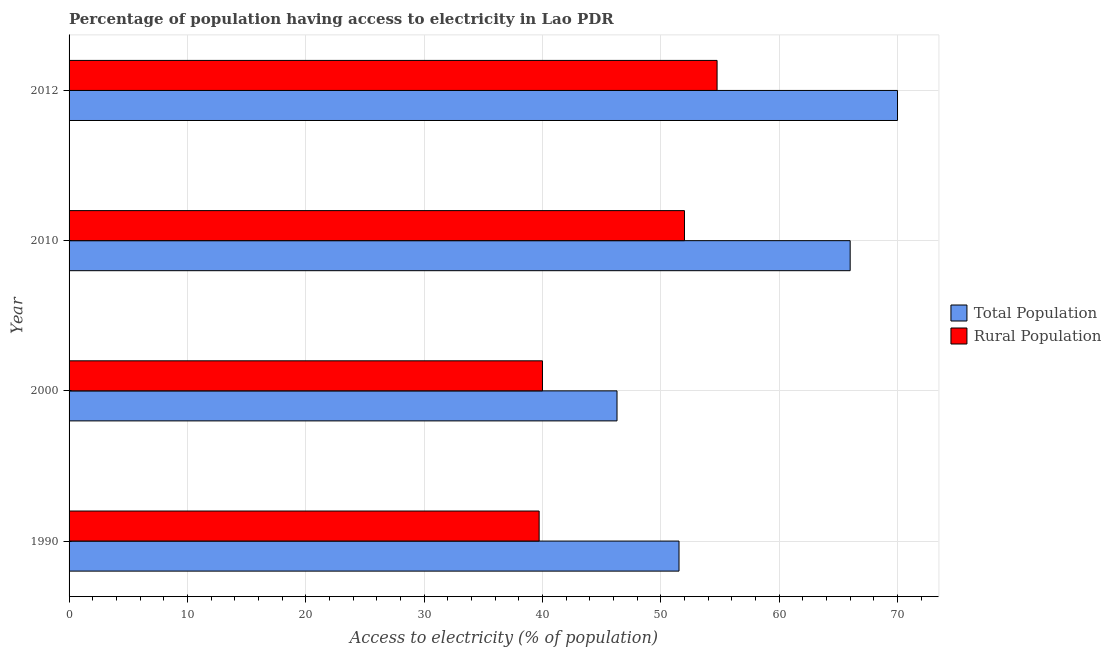How many different coloured bars are there?
Give a very brief answer. 2. How many groups of bars are there?
Offer a terse response. 4. Are the number of bars per tick equal to the number of legend labels?
Offer a very short reply. Yes. Are the number of bars on each tick of the Y-axis equal?
Offer a very short reply. Yes. How many bars are there on the 3rd tick from the bottom?
Your response must be concise. 2. In how many cases, is the number of bars for a given year not equal to the number of legend labels?
Give a very brief answer. 0. Across all years, what is the minimum percentage of population having access to electricity?
Your answer should be very brief. 46.3. In which year was the percentage of population having access to electricity maximum?
Make the answer very short. 2012. In which year was the percentage of population having access to electricity minimum?
Keep it short and to the point. 2000. What is the total percentage of population having access to electricity in the graph?
Your answer should be very brief. 233.84. What is the difference between the percentage of population having access to electricity in 1990 and that in 2012?
Your answer should be compact. -18.46. What is the difference between the percentage of rural population having access to electricity in 2012 and the percentage of population having access to electricity in 2010?
Your answer should be very brief. -11.25. What is the average percentage of population having access to electricity per year?
Your answer should be compact. 58.46. In the year 2012, what is the difference between the percentage of population having access to electricity and percentage of rural population having access to electricity?
Provide a succinct answer. 15.24. What is the ratio of the percentage of population having access to electricity in 2010 to that in 2012?
Your response must be concise. 0.94. Is the percentage of population having access to electricity in 1990 less than that in 2000?
Your answer should be very brief. No. What is the difference between the highest and the second highest percentage of population having access to electricity?
Give a very brief answer. 4. What is the difference between the highest and the lowest percentage of rural population having access to electricity?
Your answer should be very brief. 15.03. What does the 1st bar from the top in 2012 represents?
Ensure brevity in your answer.  Rural Population. What does the 2nd bar from the bottom in 1990 represents?
Your answer should be very brief. Rural Population. How many bars are there?
Your response must be concise. 8. How many years are there in the graph?
Your answer should be very brief. 4. Are the values on the major ticks of X-axis written in scientific E-notation?
Offer a terse response. No. Does the graph contain any zero values?
Offer a terse response. No. How many legend labels are there?
Your answer should be very brief. 2. What is the title of the graph?
Provide a short and direct response. Percentage of population having access to electricity in Lao PDR. Does "Quality of trade" appear as one of the legend labels in the graph?
Your response must be concise. No. What is the label or title of the X-axis?
Offer a very short reply. Access to electricity (% of population). What is the label or title of the Y-axis?
Make the answer very short. Year. What is the Access to electricity (% of population) of Total Population in 1990?
Provide a succinct answer. 51.54. What is the Access to electricity (% of population) of Rural Population in 1990?
Offer a terse response. 39.72. What is the Access to electricity (% of population) of Total Population in 2000?
Your response must be concise. 46.3. What is the Access to electricity (% of population) in Total Population in 2010?
Make the answer very short. 66. What is the Access to electricity (% of population) of Rural Population in 2010?
Keep it short and to the point. 52. What is the Access to electricity (% of population) of Total Population in 2012?
Your answer should be compact. 70. What is the Access to electricity (% of population) of Rural Population in 2012?
Provide a succinct answer. 54.75. Across all years, what is the maximum Access to electricity (% of population) of Rural Population?
Give a very brief answer. 54.75. Across all years, what is the minimum Access to electricity (% of population) of Total Population?
Offer a terse response. 46.3. Across all years, what is the minimum Access to electricity (% of population) in Rural Population?
Provide a succinct answer. 39.72. What is the total Access to electricity (% of population) of Total Population in the graph?
Offer a terse response. 233.84. What is the total Access to electricity (% of population) of Rural Population in the graph?
Keep it short and to the point. 186.47. What is the difference between the Access to electricity (% of population) in Total Population in 1990 and that in 2000?
Provide a succinct answer. 5.24. What is the difference between the Access to electricity (% of population) in Rural Population in 1990 and that in 2000?
Provide a succinct answer. -0.28. What is the difference between the Access to electricity (% of population) in Total Population in 1990 and that in 2010?
Your answer should be compact. -14.46. What is the difference between the Access to electricity (% of population) of Rural Population in 1990 and that in 2010?
Keep it short and to the point. -12.28. What is the difference between the Access to electricity (% of population) in Total Population in 1990 and that in 2012?
Your answer should be very brief. -18.46. What is the difference between the Access to electricity (% of population) in Rural Population in 1990 and that in 2012?
Keep it short and to the point. -15.03. What is the difference between the Access to electricity (% of population) of Total Population in 2000 and that in 2010?
Make the answer very short. -19.7. What is the difference between the Access to electricity (% of population) in Total Population in 2000 and that in 2012?
Offer a terse response. -23.7. What is the difference between the Access to electricity (% of population) in Rural Population in 2000 and that in 2012?
Your answer should be compact. -14.75. What is the difference between the Access to electricity (% of population) in Total Population in 2010 and that in 2012?
Your response must be concise. -4. What is the difference between the Access to electricity (% of population) of Rural Population in 2010 and that in 2012?
Make the answer very short. -2.75. What is the difference between the Access to electricity (% of population) in Total Population in 1990 and the Access to electricity (% of population) in Rural Population in 2000?
Provide a succinct answer. 11.54. What is the difference between the Access to electricity (% of population) in Total Population in 1990 and the Access to electricity (% of population) in Rural Population in 2010?
Your answer should be compact. -0.46. What is the difference between the Access to electricity (% of population) of Total Population in 1990 and the Access to electricity (% of population) of Rural Population in 2012?
Your answer should be compact. -3.22. What is the difference between the Access to electricity (% of population) of Total Population in 2000 and the Access to electricity (% of population) of Rural Population in 2012?
Provide a short and direct response. -8.45. What is the difference between the Access to electricity (% of population) in Total Population in 2010 and the Access to electricity (% of population) in Rural Population in 2012?
Your response must be concise. 11.25. What is the average Access to electricity (% of population) in Total Population per year?
Provide a short and direct response. 58.46. What is the average Access to electricity (% of population) of Rural Population per year?
Keep it short and to the point. 46.62. In the year 1990, what is the difference between the Access to electricity (% of population) of Total Population and Access to electricity (% of population) of Rural Population?
Keep it short and to the point. 11.82. In the year 2000, what is the difference between the Access to electricity (% of population) of Total Population and Access to electricity (% of population) of Rural Population?
Ensure brevity in your answer.  6.3. In the year 2010, what is the difference between the Access to electricity (% of population) of Total Population and Access to electricity (% of population) of Rural Population?
Keep it short and to the point. 14. In the year 2012, what is the difference between the Access to electricity (% of population) of Total Population and Access to electricity (% of population) of Rural Population?
Provide a succinct answer. 15.25. What is the ratio of the Access to electricity (% of population) in Total Population in 1990 to that in 2000?
Your response must be concise. 1.11. What is the ratio of the Access to electricity (% of population) of Total Population in 1990 to that in 2010?
Offer a very short reply. 0.78. What is the ratio of the Access to electricity (% of population) of Rural Population in 1990 to that in 2010?
Your answer should be very brief. 0.76. What is the ratio of the Access to electricity (% of population) in Total Population in 1990 to that in 2012?
Provide a short and direct response. 0.74. What is the ratio of the Access to electricity (% of population) in Rural Population in 1990 to that in 2012?
Make the answer very short. 0.73. What is the ratio of the Access to electricity (% of population) in Total Population in 2000 to that in 2010?
Offer a terse response. 0.7. What is the ratio of the Access to electricity (% of population) in Rural Population in 2000 to that in 2010?
Ensure brevity in your answer.  0.77. What is the ratio of the Access to electricity (% of population) in Total Population in 2000 to that in 2012?
Your response must be concise. 0.66. What is the ratio of the Access to electricity (% of population) in Rural Population in 2000 to that in 2012?
Your answer should be compact. 0.73. What is the ratio of the Access to electricity (% of population) of Total Population in 2010 to that in 2012?
Provide a succinct answer. 0.94. What is the ratio of the Access to electricity (% of population) of Rural Population in 2010 to that in 2012?
Your answer should be very brief. 0.95. What is the difference between the highest and the second highest Access to electricity (% of population) in Total Population?
Give a very brief answer. 4. What is the difference between the highest and the second highest Access to electricity (% of population) of Rural Population?
Give a very brief answer. 2.75. What is the difference between the highest and the lowest Access to electricity (% of population) in Total Population?
Ensure brevity in your answer.  23.7. What is the difference between the highest and the lowest Access to electricity (% of population) in Rural Population?
Ensure brevity in your answer.  15.03. 